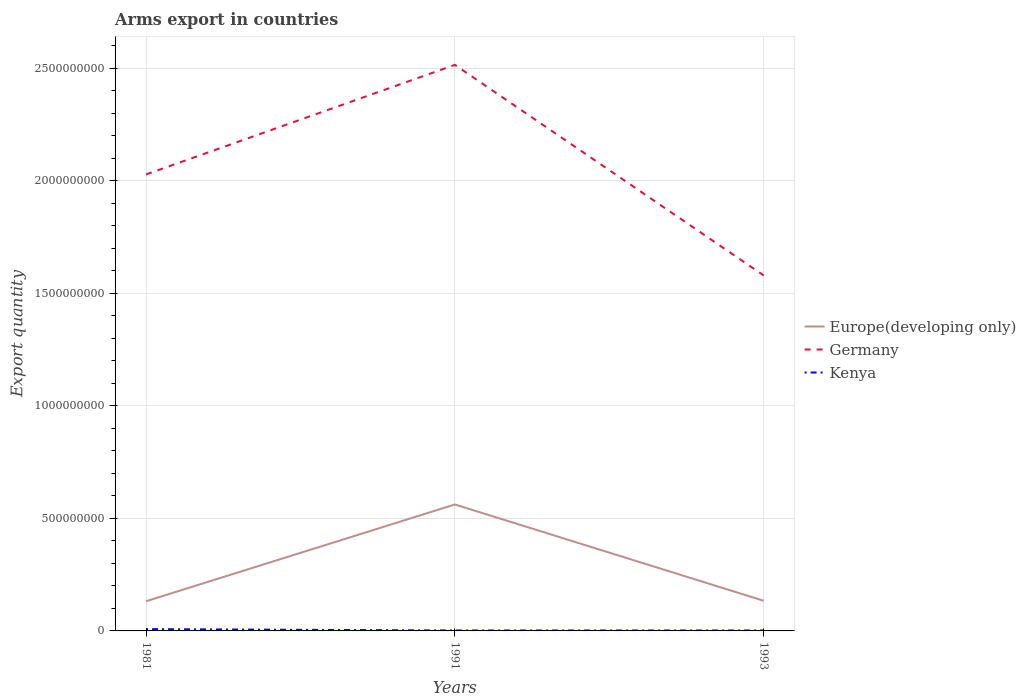How many different coloured lines are there?
Your answer should be compact. 3. Is the number of lines equal to the number of legend labels?
Offer a very short reply. Yes. In which year was the total arms export in Europe(developing only) maximum?
Give a very brief answer. 1981. What is the total total arms export in Germany in the graph?
Give a very brief answer. 4.49e+08. What is the difference between the highest and the second highest total arms export in Germany?
Offer a terse response. 9.36e+08. How many lines are there?
Make the answer very short. 3. How many years are there in the graph?
Provide a succinct answer. 3. Does the graph contain any zero values?
Provide a short and direct response. No. Where does the legend appear in the graph?
Ensure brevity in your answer.  Center right. What is the title of the graph?
Give a very brief answer. Arms export in countries. What is the label or title of the X-axis?
Give a very brief answer. Years. What is the label or title of the Y-axis?
Offer a terse response. Export quantity. What is the Export quantity in Europe(developing only) in 1981?
Offer a very short reply. 1.32e+08. What is the Export quantity of Germany in 1981?
Offer a terse response. 2.03e+09. What is the Export quantity of Kenya in 1981?
Give a very brief answer. 8.00e+06. What is the Export quantity of Europe(developing only) in 1991?
Make the answer very short. 5.62e+08. What is the Export quantity of Germany in 1991?
Ensure brevity in your answer.  2.52e+09. What is the Export quantity in Europe(developing only) in 1993?
Give a very brief answer. 1.34e+08. What is the Export quantity in Germany in 1993?
Provide a succinct answer. 1.58e+09. Across all years, what is the maximum Export quantity of Europe(developing only)?
Your answer should be very brief. 5.62e+08. Across all years, what is the maximum Export quantity in Germany?
Give a very brief answer. 2.52e+09. Across all years, what is the maximum Export quantity in Kenya?
Provide a succinct answer. 8.00e+06. Across all years, what is the minimum Export quantity in Europe(developing only)?
Your answer should be very brief. 1.32e+08. Across all years, what is the minimum Export quantity in Germany?
Give a very brief answer. 1.58e+09. Across all years, what is the minimum Export quantity in Kenya?
Provide a short and direct response. 2.00e+06. What is the total Export quantity in Europe(developing only) in the graph?
Your answer should be compact. 8.28e+08. What is the total Export quantity in Germany in the graph?
Offer a very short reply. 6.12e+09. What is the difference between the Export quantity in Europe(developing only) in 1981 and that in 1991?
Keep it short and to the point. -4.30e+08. What is the difference between the Export quantity in Germany in 1981 and that in 1991?
Keep it short and to the point. -4.87e+08. What is the difference between the Export quantity in Kenya in 1981 and that in 1991?
Make the answer very short. 6.00e+06. What is the difference between the Export quantity of Europe(developing only) in 1981 and that in 1993?
Your answer should be compact. -2.00e+06. What is the difference between the Export quantity in Germany in 1981 and that in 1993?
Ensure brevity in your answer.  4.49e+08. What is the difference between the Export quantity in Kenya in 1981 and that in 1993?
Offer a terse response. 6.00e+06. What is the difference between the Export quantity of Europe(developing only) in 1991 and that in 1993?
Ensure brevity in your answer.  4.28e+08. What is the difference between the Export quantity in Germany in 1991 and that in 1993?
Give a very brief answer. 9.36e+08. What is the difference between the Export quantity in Europe(developing only) in 1981 and the Export quantity in Germany in 1991?
Provide a short and direct response. -2.38e+09. What is the difference between the Export quantity of Europe(developing only) in 1981 and the Export quantity of Kenya in 1991?
Provide a short and direct response. 1.30e+08. What is the difference between the Export quantity in Germany in 1981 and the Export quantity in Kenya in 1991?
Ensure brevity in your answer.  2.03e+09. What is the difference between the Export quantity of Europe(developing only) in 1981 and the Export quantity of Germany in 1993?
Your answer should be compact. -1.45e+09. What is the difference between the Export quantity of Europe(developing only) in 1981 and the Export quantity of Kenya in 1993?
Give a very brief answer. 1.30e+08. What is the difference between the Export quantity in Germany in 1981 and the Export quantity in Kenya in 1993?
Keep it short and to the point. 2.03e+09. What is the difference between the Export quantity in Europe(developing only) in 1991 and the Export quantity in Germany in 1993?
Ensure brevity in your answer.  -1.02e+09. What is the difference between the Export quantity of Europe(developing only) in 1991 and the Export quantity of Kenya in 1993?
Provide a short and direct response. 5.60e+08. What is the difference between the Export quantity in Germany in 1991 and the Export quantity in Kenya in 1993?
Provide a short and direct response. 2.51e+09. What is the average Export quantity in Europe(developing only) per year?
Keep it short and to the point. 2.76e+08. What is the average Export quantity in Germany per year?
Keep it short and to the point. 2.04e+09. In the year 1981, what is the difference between the Export quantity in Europe(developing only) and Export quantity in Germany?
Provide a succinct answer. -1.90e+09. In the year 1981, what is the difference between the Export quantity of Europe(developing only) and Export quantity of Kenya?
Ensure brevity in your answer.  1.24e+08. In the year 1981, what is the difference between the Export quantity in Germany and Export quantity in Kenya?
Make the answer very short. 2.02e+09. In the year 1991, what is the difference between the Export quantity of Europe(developing only) and Export quantity of Germany?
Give a very brief answer. -1.95e+09. In the year 1991, what is the difference between the Export quantity in Europe(developing only) and Export quantity in Kenya?
Keep it short and to the point. 5.60e+08. In the year 1991, what is the difference between the Export quantity of Germany and Export quantity of Kenya?
Your answer should be very brief. 2.51e+09. In the year 1993, what is the difference between the Export quantity in Europe(developing only) and Export quantity in Germany?
Your response must be concise. -1.45e+09. In the year 1993, what is the difference between the Export quantity of Europe(developing only) and Export quantity of Kenya?
Keep it short and to the point. 1.32e+08. In the year 1993, what is the difference between the Export quantity of Germany and Export quantity of Kenya?
Your answer should be compact. 1.58e+09. What is the ratio of the Export quantity of Europe(developing only) in 1981 to that in 1991?
Make the answer very short. 0.23. What is the ratio of the Export quantity of Germany in 1981 to that in 1991?
Offer a terse response. 0.81. What is the ratio of the Export quantity of Europe(developing only) in 1981 to that in 1993?
Your response must be concise. 0.99. What is the ratio of the Export quantity in Germany in 1981 to that in 1993?
Give a very brief answer. 1.28. What is the ratio of the Export quantity of Europe(developing only) in 1991 to that in 1993?
Offer a very short reply. 4.19. What is the ratio of the Export quantity in Germany in 1991 to that in 1993?
Make the answer very short. 1.59. What is the ratio of the Export quantity of Kenya in 1991 to that in 1993?
Ensure brevity in your answer.  1. What is the difference between the highest and the second highest Export quantity in Europe(developing only)?
Provide a succinct answer. 4.28e+08. What is the difference between the highest and the second highest Export quantity in Germany?
Give a very brief answer. 4.87e+08. What is the difference between the highest and the lowest Export quantity of Europe(developing only)?
Your answer should be compact. 4.30e+08. What is the difference between the highest and the lowest Export quantity of Germany?
Make the answer very short. 9.36e+08. What is the difference between the highest and the lowest Export quantity in Kenya?
Offer a very short reply. 6.00e+06. 